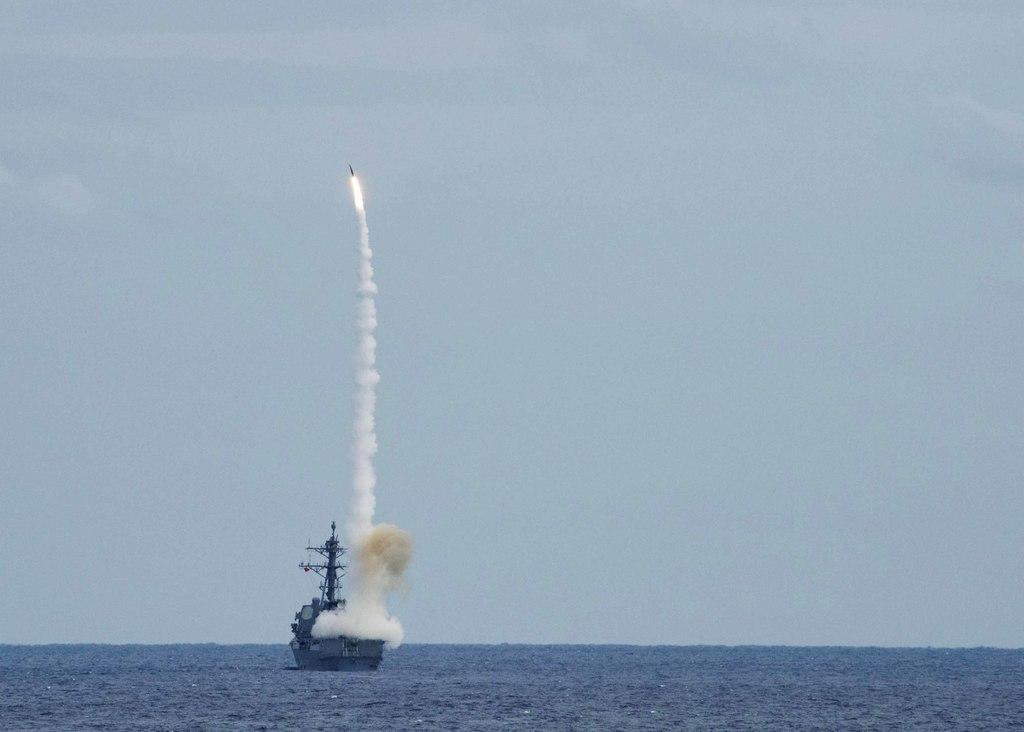Describe this image in one or two sentences. In this picture, we can see a boat, water, the rocket, smoke and the sky. 